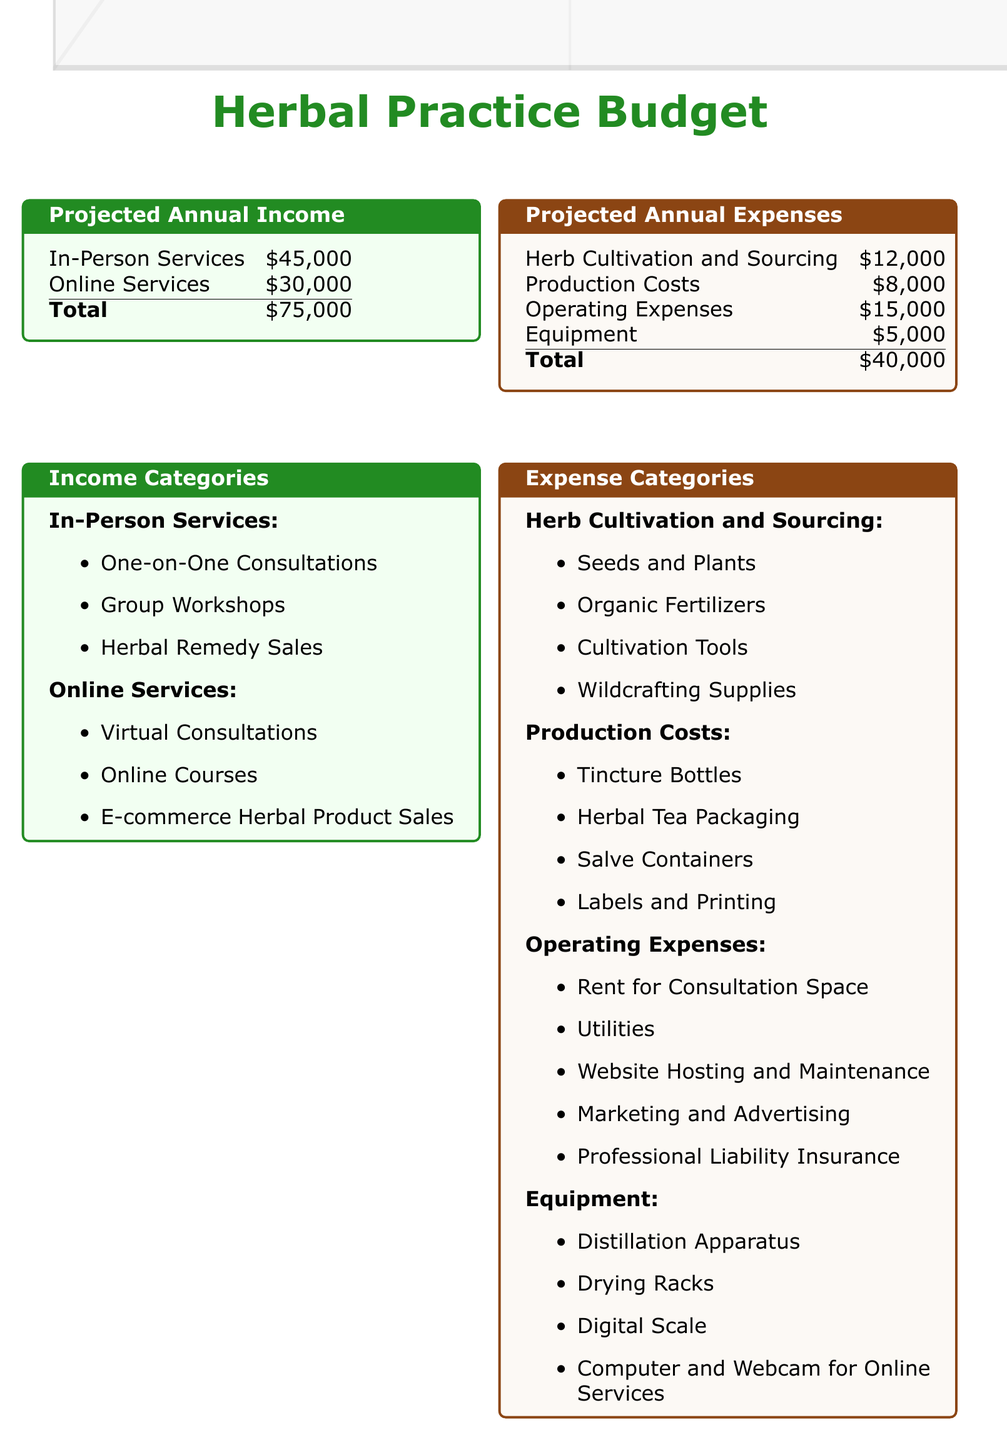What is the total projected annual income? The total projected annual income is indicated as the sum of in-person and online services in the document.
Answer: $75,000 What are the projected expenses for equipment? The expense category mentions a specific cost associated with equipment, which is part of the total expenses.
Answer: $5,000 How much is budgeted for herb cultivation and sourcing? The document specifies the amount allocated for herb cultivation and sourcing as part of the total projected annual expenses.
Answer: $12,000 What are the income categories for in-person services? The document lists the specific services that comprise in-person income, detailing the sources of revenue.
Answer: One-on-One Consultations, Group Workshops, Herbal Remedy Sales What is the net profit projection? The net profit projection is calculated from the total income minus total expenses as provided in the document.
Answer: $35,000 What is the total projected annual expenses? The total projected annual expenses are the sum of all expense categories listed in the document.
Answer: $40,000 What online service is included for income generation? The document lists various services that contribute to online income, focusing on digital offerings.
Answer: Virtual Consultations How much are production costs budgeted? The amount for production costs is specifically detailed in the expenses section of the document.
Answer: $8,000 What expense category includes marketing? The expense categories specify where marketing and advertising costs are accounted for within the overall budget.
Answer: Operating Expenses 